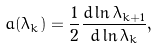<formula> <loc_0><loc_0><loc_500><loc_500>a ( \lambda _ { k } ) = \frac { 1 } { 2 } \frac { d \ln \lambda _ { k + 1 } } { d \ln \lambda _ { k } } ,</formula> 